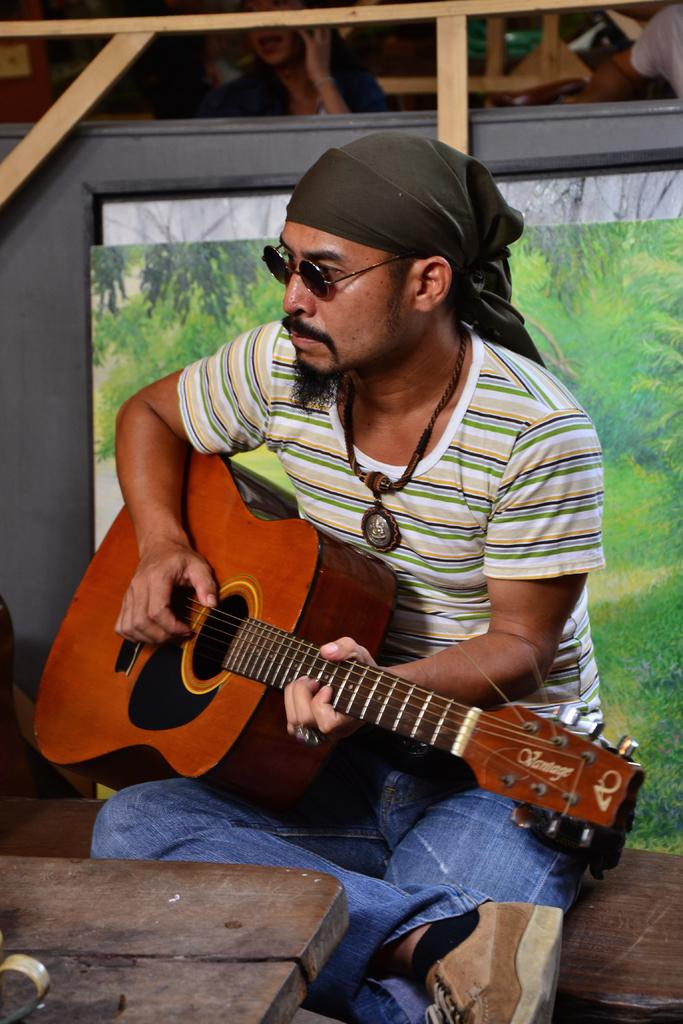What is present in the image? There is a person in the image. Can you describe the person's clothing? The person is wearing a green, white, and black shirt and blue pants. What is the person holding in the image? The person is holding a musical instrument. What is the person doing with the musical instrument? The person is playing the musical instrument. What decision did the person make regarding their school unit in the image? There is no reference to school, units, or decisions in the image. 